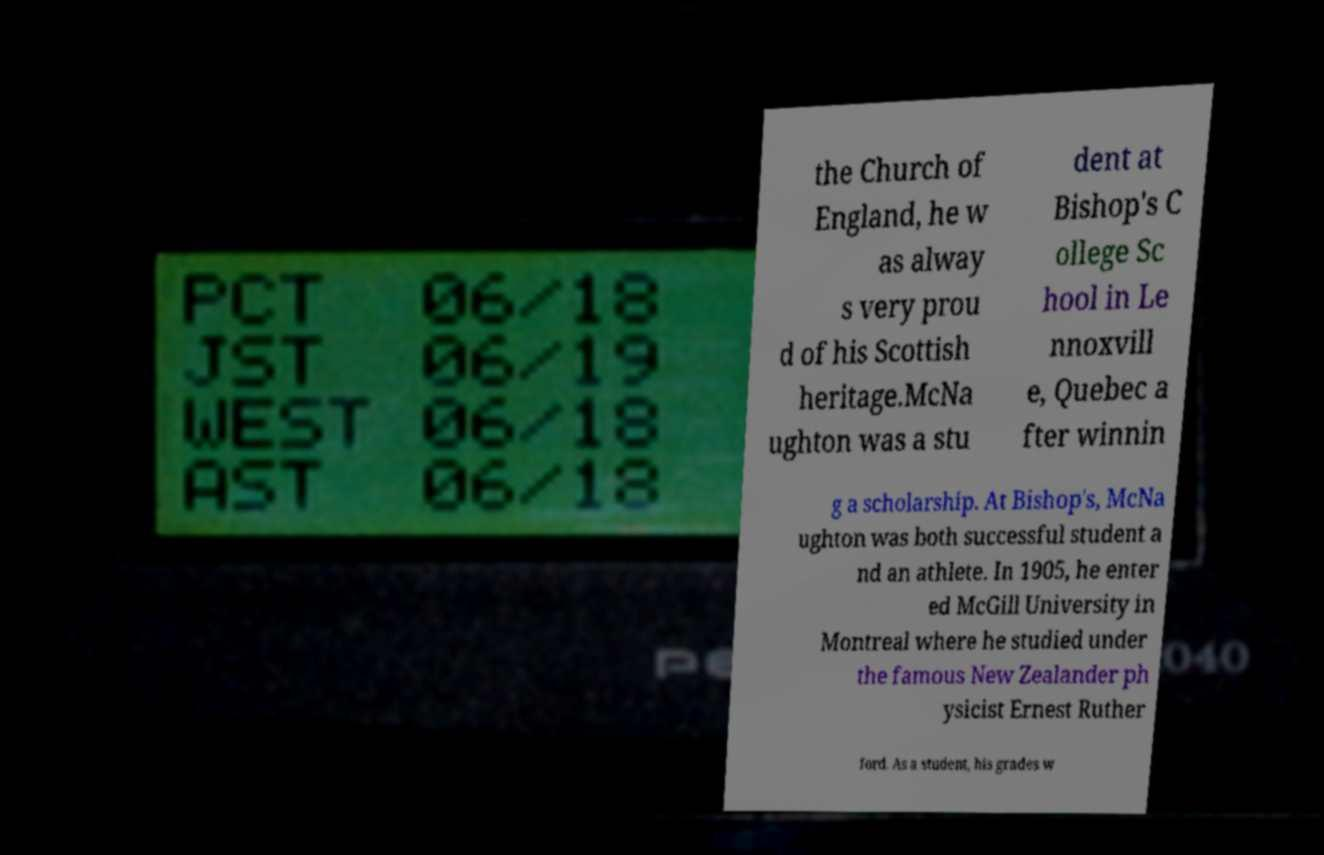Can you read and provide the text displayed in the image?This photo seems to have some interesting text. Can you extract and type it out for me? the Church of England, he w as alway s very prou d of his Scottish heritage.McNa ughton was a stu dent at Bishop's C ollege Sc hool in Le nnoxvill e, Quebec a fter winnin g a scholarship. At Bishop's, McNa ughton was both successful student a nd an athlete. In 1905, he enter ed McGill University in Montreal where he studied under the famous New Zealander ph ysicist Ernest Ruther ford. As a student, his grades w 